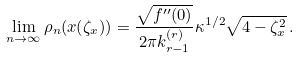<formula> <loc_0><loc_0><loc_500><loc_500>\lim _ { n \to \infty } \rho _ { n } ( x ( \zeta _ { x } ) ) = \frac { \sqrt { f ^ { \prime \prime } ( 0 ) } } { 2 \pi k _ { r - 1 } ^ { ( r ) } } \kappa ^ { 1 / 2 } \sqrt { 4 - \zeta _ { x } ^ { 2 } } \, .</formula> 